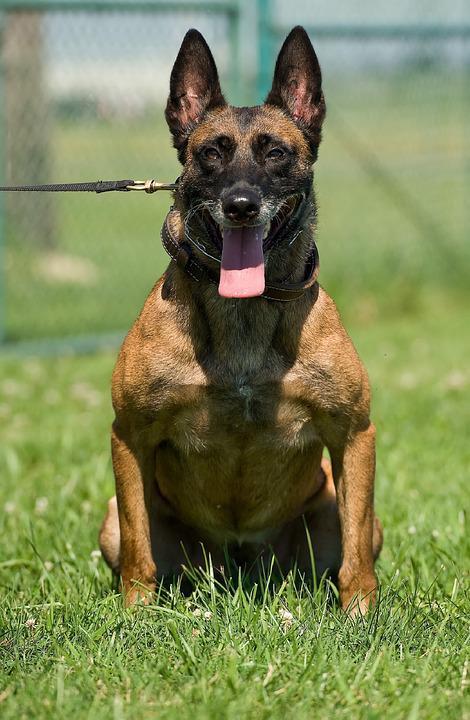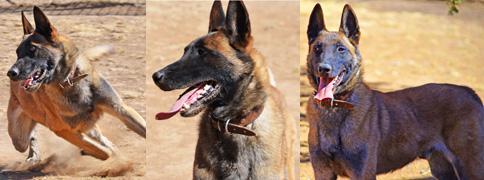The first image is the image on the left, the second image is the image on the right. For the images shown, is this caption "There are three dogs in one of the images." true? Answer yes or no. Yes. 